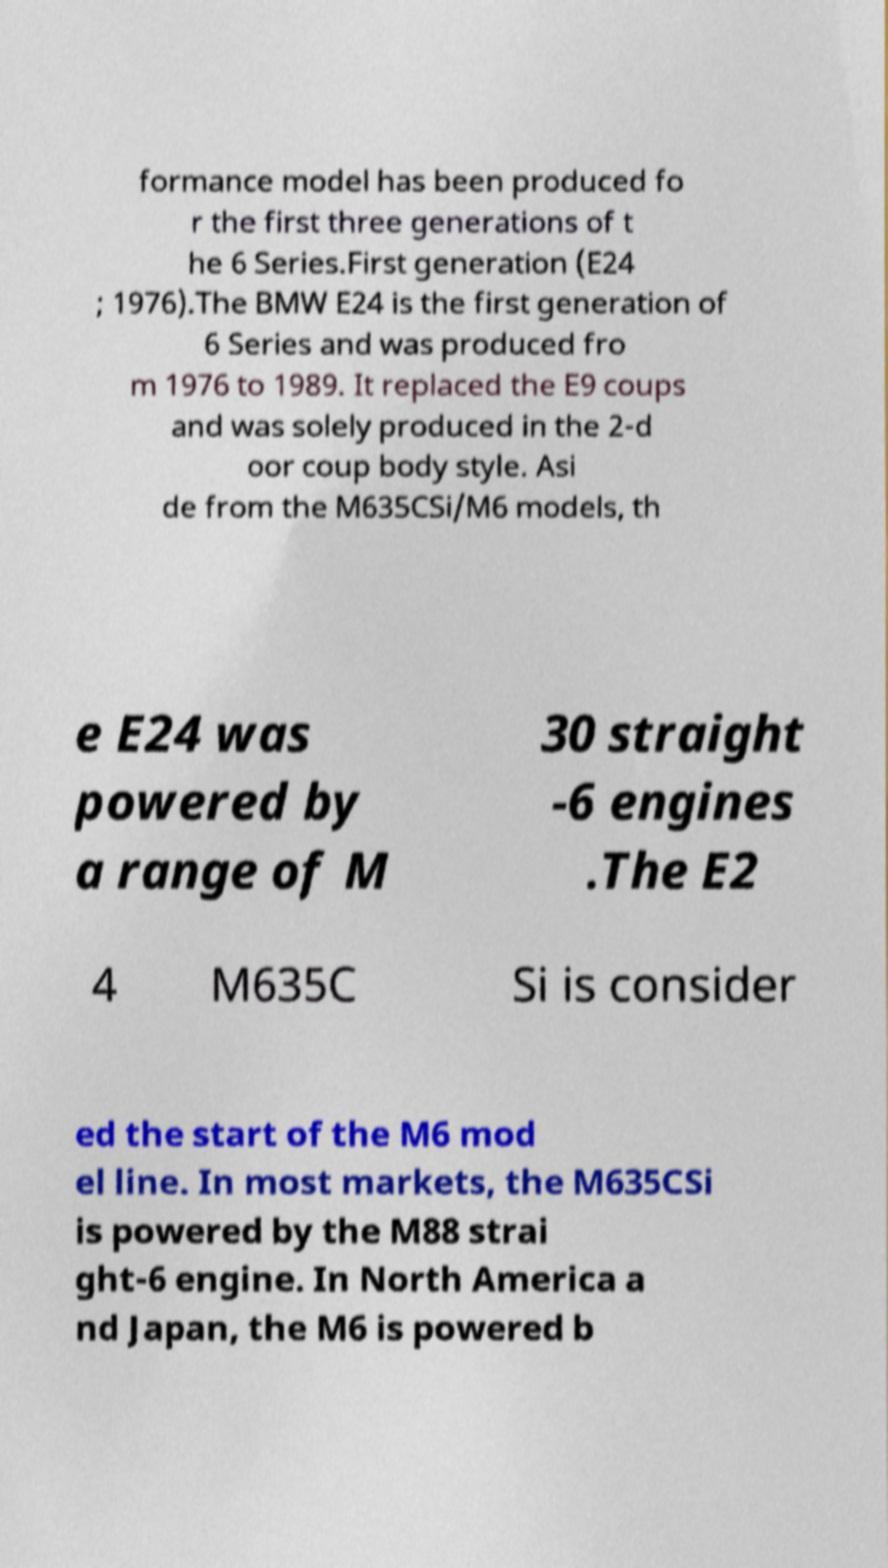There's text embedded in this image that I need extracted. Can you transcribe it verbatim? formance model has been produced fo r the first three generations of t he 6 Series.First generation (E24 ; 1976).The BMW E24 is the first generation of 6 Series and was produced fro m 1976 to 1989. It replaced the E9 coups and was solely produced in the 2-d oor coup body style. Asi de from the M635CSi/M6 models, th e E24 was powered by a range of M 30 straight -6 engines .The E2 4 M635C Si is consider ed the start of the M6 mod el line. In most markets, the M635CSi is powered by the M88 strai ght-6 engine. In North America a nd Japan, the M6 is powered b 